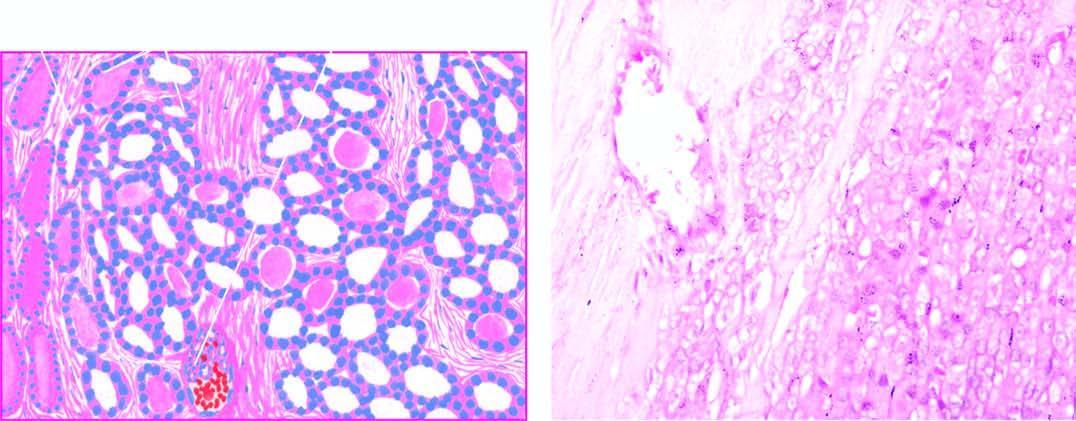what is mild pleomorphism?
Answer the question using a single word or phrase. There 